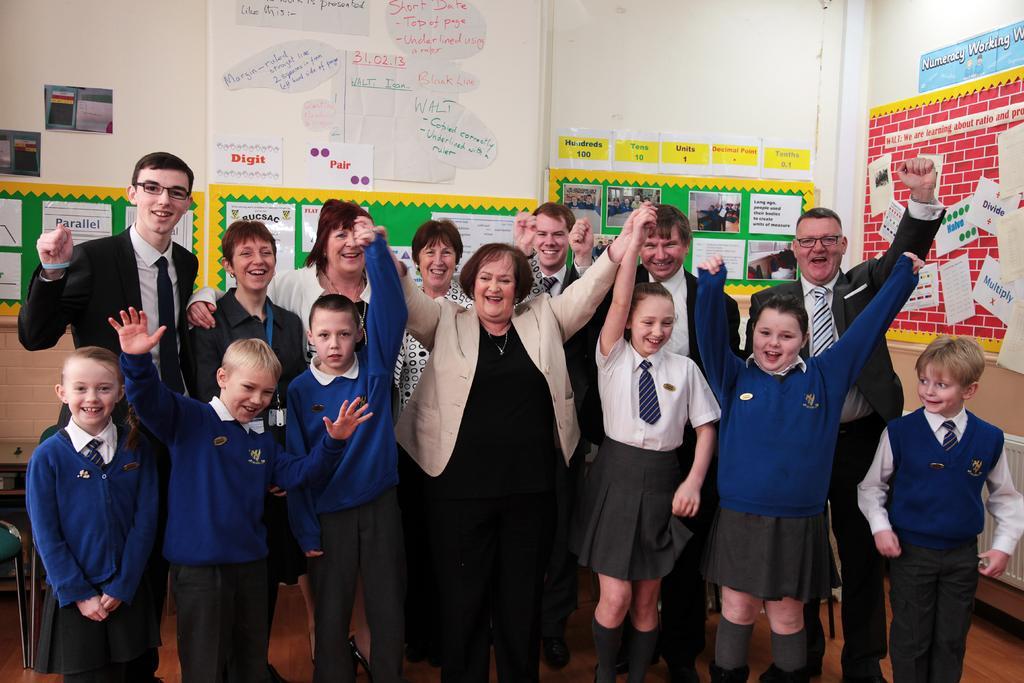Describe this image in one or two sentences. Here we can see group of people standing on the floor and they are smiling. In the background we can see posters and a wall. 